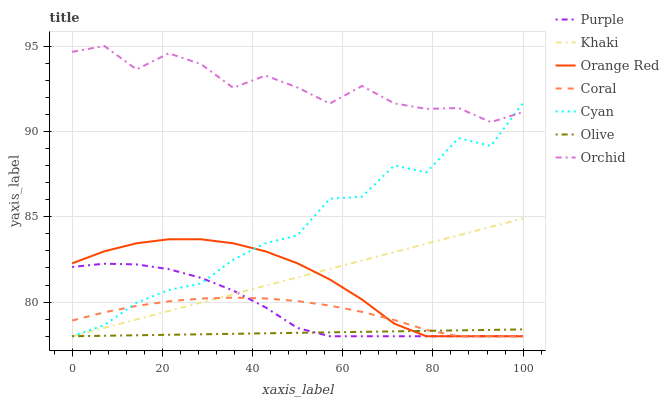Does Olive have the minimum area under the curve?
Answer yes or no. Yes. Does Orchid have the maximum area under the curve?
Answer yes or no. Yes. Does Purple have the minimum area under the curve?
Answer yes or no. No. Does Purple have the maximum area under the curve?
Answer yes or no. No. Is Khaki the smoothest?
Answer yes or no. Yes. Is Cyan the roughest?
Answer yes or no. Yes. Is Purple the smoothest?
Answer yes or no. No. Is Purple the roughest?
Answer yes or no. No. Does Khaki have the lowest value?
Answer yes or no. Yes. Does Orchid have the lowest value?
Answer yes or no. No. Does Orchid have the highest value?
Answer yes or no. Yes. Does Purple have the highest value?
Answer yes or no. No. Is Khaki less than Orchid?
Answer yes or no. Yes. Is Orchid greater than Khaki?
Answer yes or no. Yes. Does Purple intersect Khaki?
Answer yes or no. Yes. Is Purple less than Khaki?
Answer yes or no. No. Is Purple greater than Khaki?
Answer yes or no. No. Does Khaki intersect Orchid?
Answer yes or no. No. 